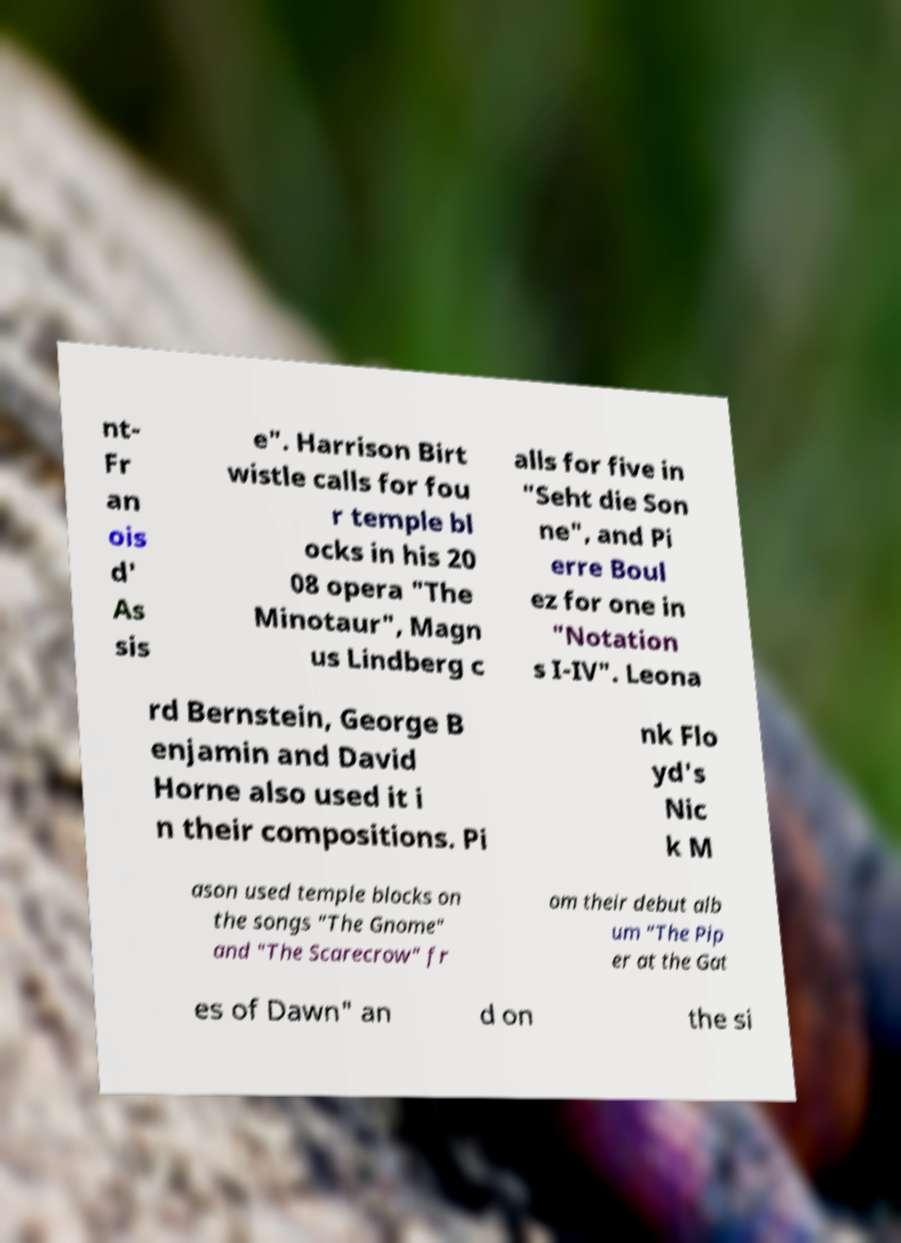Please read and relay the text visible in this image. What does it say? nt- Fr an ois d' As sis e". Harrison Birt wistle calls for fou r temple bl ocks in his 20 08 opera "The Minotaur", Magn us Lindberg c alls for five in "Seht die Son ne", and Pi erre Boul ez for one in "Notation s I-IV". Leona rd Bernstein, George B enjamin and David Horne also used it i n their compositions. Pi nk Flo yd's Nic k M ason used temple blocks on the songs "The Gnome" and "The Scarecrow" fr om their debut alb um "The Pip er at the Gat es of Dawn" an d on the si 